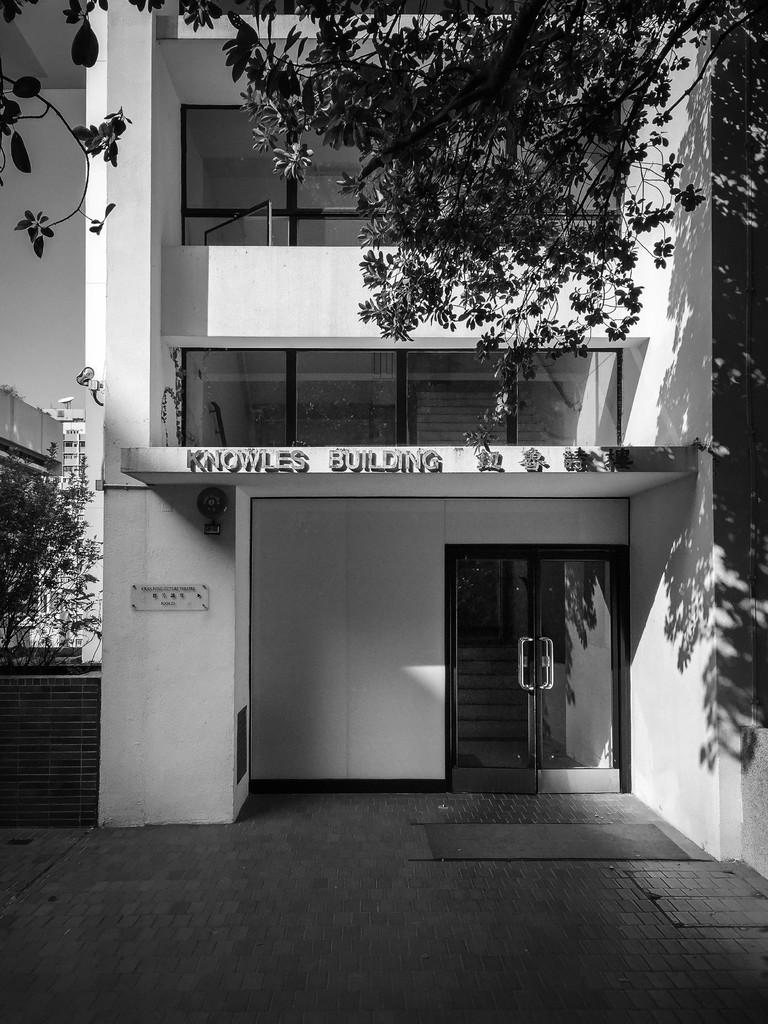What is the color scheme of the image? The image is black and white and white. What type of structures can be seen in the image? There are buildings in the image. Can you describe a specific feature of one of the buildings? There is a door in the image, which is a feature of one of the buildings. What other objects can be seen in the image? There is a board and trees in the image. What material is present in the image? There is glass in the image. What part of the natural environment is visible in the image? The sky is visible in the image. What type of beef is being cooked on the appliance in the image? There is no beef or appliance present in the image; it is a black and white image featuring buildings, a door, a board, trees, glass, and the sky. 